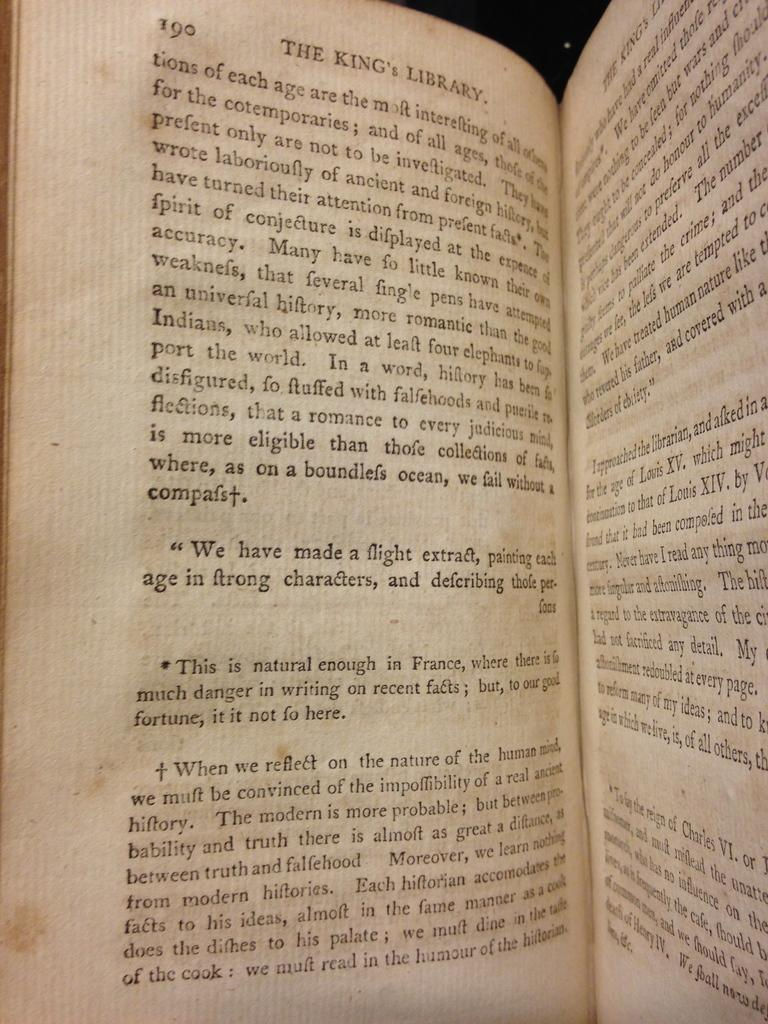<image>
Provide a brief description of the given image. A book called The Kings Library is open to page 190. 